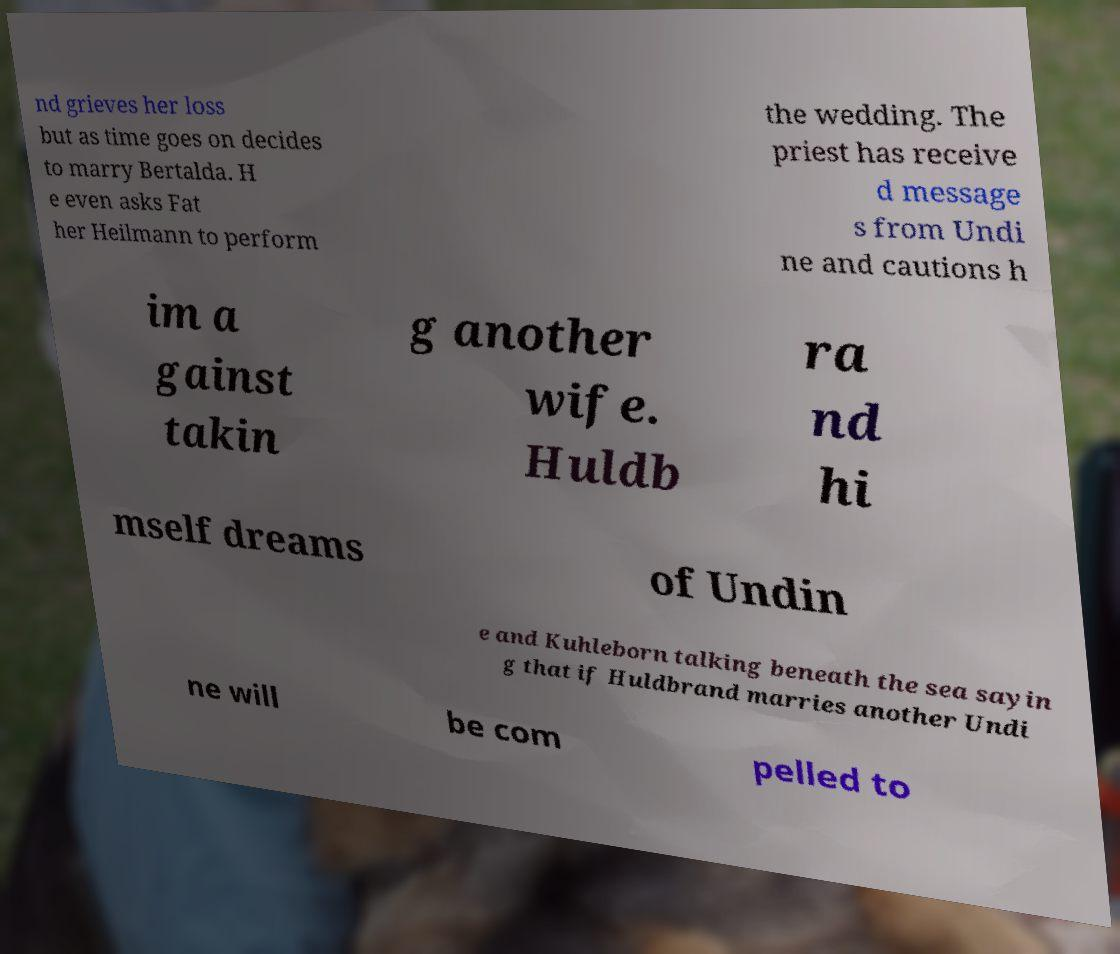Can you accurately transcribe the text from the provided image for me? nd grieves her loss but as time goes on decides to marry Bertalda. H e even asks Fat her Heilmann to perform the wedding. The priest has receive d message s from Undi ne and cautions h im a gainst takin g another wife. Huldb ra nd hi mself dreams of Undin e and Kuhleborn talking beneath the sea sayin g that if Huldbrand marries another Undi ne will be com pelled to 